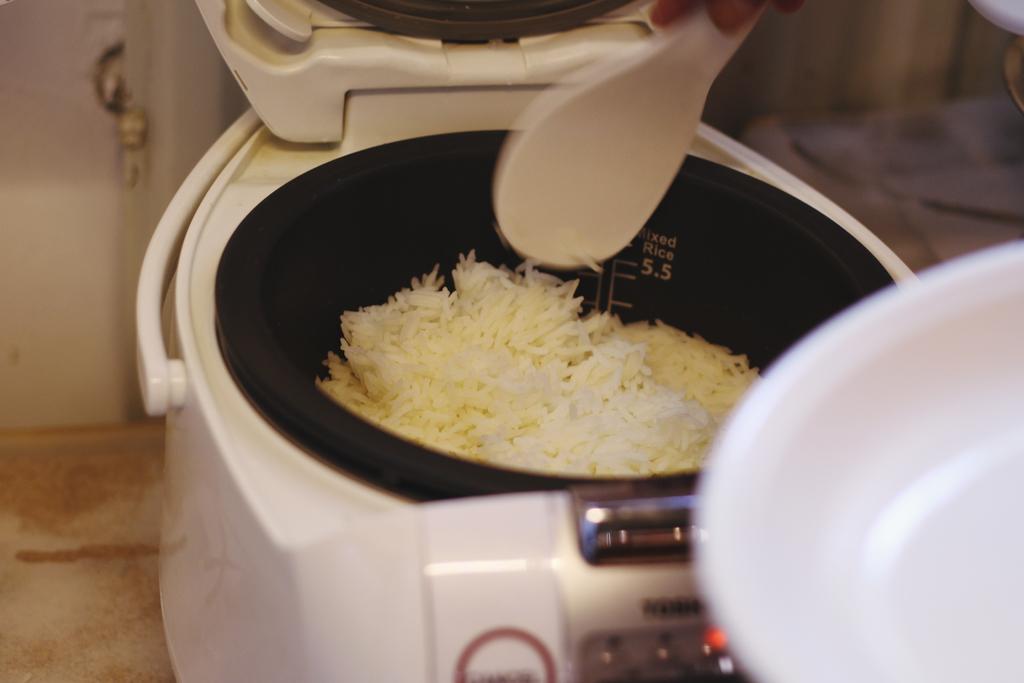What number is printed on the inside of the rice cooker?
Offer a very short reply. 5.5. Does this rice cooker have a built in measure?
Your answer should be very brief. Yes. 